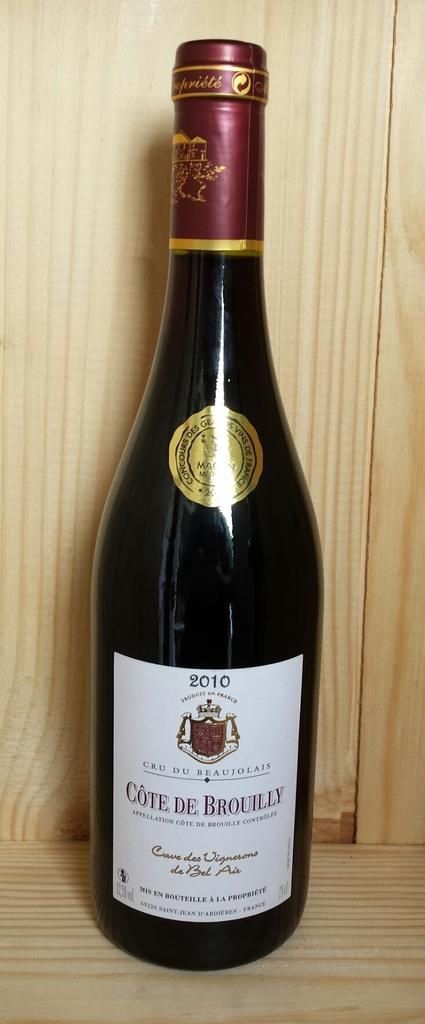Who made the wine?
Keep it short and to the point. Cote de brouilly. 